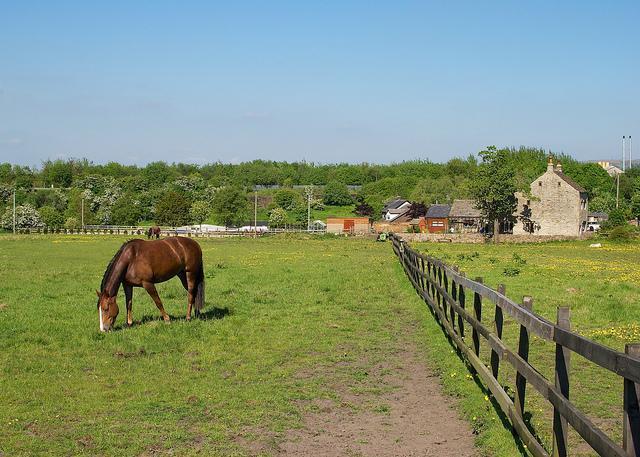How many people are on the bench?
Give a very brief answer. 0. 